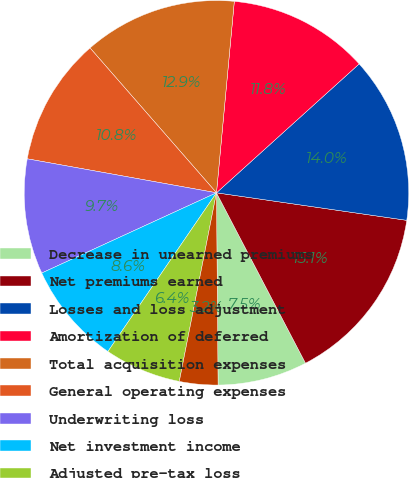Convert chart. <chart><loc_0><loc_0><loc_500><loc_500><pie_chart><fcel>Decrease in unearned premiums<fcel>Net premiums earned<fcel>Losses and loss adjustment<fcel>Amortization of deferred<fcel>Total acquisition expenses<fcel>General operating expenses<fcel>Underwriting loss<fcel>Net investment income<fcel>Adjusted pre-tax loss<fcel>Loss ratio (a)<nl><fcel>7.53%<fcel>15.05%<fcel>13.98%<fcel>11.83%<fcel>12.9%<fcel>10.75%<fcel>9.68%<fcel>8.6%<fcel>6.45%<fcel>3.23%<nl></chart> 